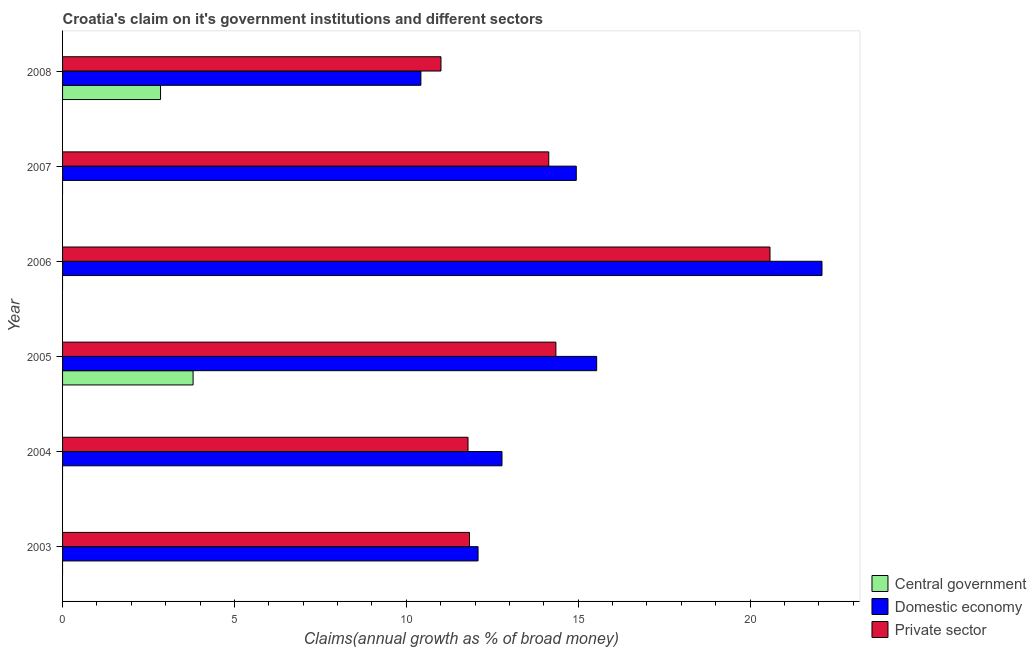How many different coloured bars are there?
Your response must be concise. 3. Are the number of bars per tick equal to the number of legend labels?
Give a very brief answer. No. How many bars are there on the 4th tick from the bottom?
Your response must be concise. 2. What is the label of the 4th group of bars from the top?
Give a very brief answer. 2005. Across all years, what is the maximum percentage of claim on the central government?
Keep it short and to the point. 3.8. Across all years, what is the minimum percentage of claim on the private sector?
Provide a short and direct response. 11.01. What is the total percentage of claim on the central government in the graph?
Provide a short and direct response. 6.65. What is the difference between the percentage of claim on the domestic economy in 2005 and that in 2007?
Provide a succinct answer. 0.59. What is the difference between the percentage of claim on the private sector in 2007 and the percentage of claim on the domestic economy in 2005?
Provide a short and direct response. -1.39. What is the average percentage of claim on the central government per year?
Make the answer very short. 1.11. In the year 2005, what is the difference between the percentage of claim on the domestic economy and percentage of claim on the private sector?
Keep it short and to the point. 1.19. What is the ratio of the percentage of claim on the private sector in 2004 to that in 2008?
Offer a terse response. 1.07. What is the difference between the highest and the second highest percentage of claim on the domestic economy?
Your answer should be compact. 6.55. What is the difference between the highest and the lowest percentage of claim on the central government?
Ensure brevity in your answer.  3.8. In how many years, is the percentage of claim on the domestic economy greater than the average percentage of claim on the domestic economy taken over all years?
Provide a short and direct response. 3. How many bars are there?
Offer a very short reply. 14. Are all the bars in the graph horizontal?
Provide a short and direct response. Yes. Are the values on the major ticks of X-axis written in scientific E-notation?
Keep it short and to the point. No. Does the graph contain any zero values?
Provide a succinct answer. Yes. Where does the legend appear in the graph?
Ensure brevity in your answer.  Bottom right. How many legend labels are there?
Offer a very short reply. 3. What is the title of the graph?
Ensure brevity in your answer.  Croatia's claim on it's government institutions and different sectors. Does "Spain" appear as one of the legend labels in the graph?
Keep it short and to the point. No. What is the label or title of the X-axis?
Your answer should be very brief. Claims(annual growth as % of broad money). What is the Claims(annual growth as % of broad money) of Central government in 2003?
Offer a terse response. 0. What is the Claims(annual growth as % of broad money) in Domestic economy in 2003?
Make the answer very short. 12.09. What is the Claims(annual growth as % of broad money) of Private sector in 2003?
Your answer should be compact. 11.84. What is the Claims(annual growth as % of broad money) in Domestic economy in 2004?
Offer a terse response. 12.78. What is the Claims(annual growth as % of broad money) in Private sector in 2004?
Provide a succinct answer. 11.8. What is the Claims(annual growth as % of broad money) in Central government in 2005?
Provide a short and direct response. 3.8. What is the Claims(annual growth as % of broad money) in Domestic economy in 2005?
Keep it short and to the point. 15.54. What is the Claims(annual growth as % of broad money) of Private sector in 2005?
Your response must be concise. 14.35. What is the Claims(annual growth as % of broad money) of Domestic economy in 2006?
Give a very brief answer. 22.09. What is the Claims(annual growth as % of broad money) of Private sector in 2006?
Keep it short and to the point. 20.58. What is the Claims(annual growth as % of broad money) of Domestic economy in 2007?
Offer a very short reply. 14.94. What is the Claims(annual growth as % of broad money) of Private sector in 2007?
Your response must be concise. 14.14. What is the Claims(annual growth as % of broad money) of Central government in 2008?
Offer a terse response. 2.85. What is the Claims(annual growth as % of broad money) of Domestic economy in 2008?
Provide a short and direct response. 10.42. What is the Claims(annual growth as % of broad money) in Private sector in 2008?
Ensure brevity in your answer.  11.01. Across all years, what is the maximum Claims(annual growth as % of broad money) in Central government?
Ensure brevity in your answer.  3.8. Across all years, what is the maximum Claims(annual growth as % of broad money) of Domestic economy?
Provide a short and direct response. 22.09. Across all years, what is the maximum Claims(annual growth as % of broad money) of Private sector?
Offer a terse response. 20.58. Across all years, what is the minimum Claims(annual growth as % of broad money) of Domestic economy?
Make the answer very short. 10.42. Across all years, what is the minimum Claims(annual growth as % of broad money) in Private sector?
Provide a short and direct response. 11.01. What is the total Claims(annual growth as % of broad money) of Central government in the graph?
Your answer should be very brief. 6.65. What is the total Claims(annual growth as % of broad money) of Domestic economy in the graph?
Provide a short and direct response. 87.87. What is the total Claims(annual growth as % of broad money) in Private sector in the graph?
Offer a terse response. 83.72. What is the difference between the Claims(annual growth as % of broad money) in Domestic economy in 2003 and that in 2004?
Provide a succinct answer. -0.7. What is the difference between the Claims(annual growth as % of broad money) in Private sector in 2003 and that in 2004?
Offer a terse response. 0.04. What is the difference between the Claims(annual growth as % of broad money) in Domestic economy in 2003 and that in 2005?
Keep it short and to the point. -3.45. What is the difference between the Claims(annual growth as % of broad money) in Private sector in 2003 and that in 2005?
Your answer should be compact. -2.51. What is the difference between the Claims(annual growth as % of broad money) in Domestic economy in 2003 and that in 2006?
Give a very brief answer. -10.01. What is the difference between the Claims(annual growth as % of broad money) in Private sector in 2003 and that in 2006?
Keep it short and to the point. -8.74. What is the difference between the Claims(annual growth as % of broad money) in Domestic economy in 2003 and that in 2007?
Provide a succinct answer. -2.86. What is the difference between the Claims(annual growth as % of broad money) in Private sector in 2003 and that in 2007?
Ensure brevity in your answer.  -2.31. What is the difference between the Claims(annual growth as % of broad money) of Domestic economy in 2003 and that in 2008?
Offer a very short reply. 1.66. What is the difference between the Claims(annual growth as % of broad money) of Private sector in 2003 and that in 2008?
Ensure brevity in your answer.  0.83. What is the difference between the Claims(annual growth as % of broad money) in Domestic economy in 2004 and that in 2005?
Provide a succinct answer. -2.75. What is the difference between the Claims(annual growth as % of broad money) of Private sector in 2004 and that in 2005?
Give a very brief answer. -2.56. What is the difference between the Claims(annual growth as % of broad money) of Domestic economy in 2004 and that in 2006?
Provide a short and direct response. -9.31. What is the difference between the Claims(annual growth as % of broad money) in Private sector in 2004 and that in 2006?
Ensure brevity in your answer.  -8.78. What is the difference between the Claims(annual growth as % of broad money) in Domestic economy in 2004 and that in 2007?
Your answer should be very brief. -2.16. What is the difference between the Claims(annual growth as % of broad money) in Private sector in 2004 and that in 2007?
Keep it short and to the point. -2.35. What is the difference between the Claims(annual growth as % of broad money) in Domestic economy in 2004 and that in 2008?
Ensure brevity in your answer.  2.36. What is the difference between the Claims(annual growth as % of broad money) in Private sector in 2004 and that in 2008?
Offer a terse response. 0.79. What is the difference between the Claims(annual growth as % of broad money) of Domestic economy in 2005 and that in 2006?
Ensure brevity in your answer.  -6.55. What is the difference between the Claims(annual growth as % of broad money) of Private sector in 2005 and that in 2006?
Provide a short and direct response. -6.23. What is the difference between the Claims(annual growth as % of broad money) in Domestic economy in 2005 and that in 2007?
Ensure brevity in your answer.  0.59. What is the difference between the Claims(annual growth as % of broad money) in Private sector in 2005 and that in 2007?
Your answer should be compact. 0.21. What is the difference between the Claims(annual growth as % of broad money) in Central government in 2005 and that in 2008?
Your answer should be very brief. 0.95. What is the difference between the Claims(annual growth as % of broad money) of Domestic economy in 2005 and that in 2008?
Your response must be concise. 5.11. What is the difference between the Claims(annual growth as % of broad money) of Private sector in 2005 and that in 2008?
Ensure brevity in your answer.  3.34. What is the difference between the Claims(annual growth as % of broad money) in Domestic economy in 2006 and that in 2007?
Keep it short and to the point. 7.15. What is the difference between the Claims(annual growth as % of broad money) in Private sector in 2006 and that in 2007?
Ensure brevity in your answer.  6.44. What is the difference between the Claims(annual growth as % of broad money) in Domestic economy in 2006 and that in 2008?
Keep it short and to the point. 11.67. What is the difference between the Claims(annual growth as % of broad money) in Private sector in 2006 and that in 2008?
Keep it short and to the point. 9.57. What is the difference between the Claims(annual growth as % of broad money) of Domestic economy in 2007 and that in 2008?
Your answer should be compact. 4.52. What is the difference between the Claims(annual growth as % of broad money) of Private sector in 2007 and that in 2008?
Give a very brief answer. 3.14. What is the difference between the Claims(annual growth as % of broad money) in Domestic economy in 2003 and the Claims(annual growth as % of broad money) in Private sector in 2004?
Provide a short and direct response. 0.29. What is the difference between the Claims(annual growth as % of broad money) in Domestic economy in 2003 and the Claims(annual growth as % of broad money) in Private sector in 2005?
Ensure brevity in your answer.  -2.26. What is the difference between the Claims(annual growth as % of broad money) of Domestic economy in 2003 and the Claims(annual growth as % of broad money) of Private sector in 2006?
Your response must be concise. -8.49. What is the difference between the Claims(annual growth as % of broad money) of Domestic economy in 2003 and the Claims(annual growth as % of broad money) of Private sector in 2007?
Your answer should be very brief. -2.06. What is the difference between the Claims(annual growth as % of broad money) of Domestic economy in 2003 and the Claims(annual growth as % of broad money) of Private sector in 2008?
Make the answer very short. 1.08. What is the difference between the Claims(annual growth as % of broad money) of Domestic economy in 2004 and the Claims(annual growth as % of broad money) of Private sector in 2005?
Offer a terse response. -1.57. What is the difference between the Claims(annual growth as % of broad money) in Domestic economy in 2004 and the Claims(annual growth as % of broad money) in Private sector in 2006?
Your answer should be compact. -7.8. What is the difference between the Claims(annual growth as % of broad money) of Domestic economy in 2004 and the Claims(annual growth as % of broad money) of Private sector in 2007?
Offer a very short reply. -1.36. What is the difference between the Claims(annual growth as % of broad money) of Domestic economy in 2004 and the Claims(annual growth as % of broad money) of Private sector in 2008?
Offer a terse response. 1.77. What is the difference between the Claims(annual growth as % of broad money) of Central government in 2005 and the Claims(annual growth as % of broad money) of Domestic economy in 2006?
Your answer should be very brief. -18.3. What is the difference between the Claims(annual growth as % of broad money) of Central government in 2005 and the Claims(annual growth as % of broad money) of Private sector in 2006?
Your answer should be very brief. -16.78. What is the difference between the Claims(annual growth as % of broad money) of Domestic economy in 2005 and the Claims(annual growth as % of broad money) of Private sector in 2006?
Keep it short and to the point. -5.04. What is the difference between the Claims(annual growth as % of broad money) in Central government in 2005 and the Claims(annual growth as % of broad money) in Domestic economy in 2007?
Provide a succinct answer. -11.15. What is the difference between the Claims(annual growth as % of broad money) of Central government in 2005 and the Claims(annual growth as % of broad money) of Private sector in 2007?
Give a very brief answer. -10.35. What is the difference between the Claims(annual growth as % of broad money) of Domestic economy in 2005 and the Claims(annual growth as % of broad money) of Private sector in 2007?
Ensure brevity in your answer.  1.39. What is the difference between the Claims(annual growth as % of broad money) of Central government in 2005 and the Claims(annual growth as % of broad money) of Domestic economy in 2008?
Provide a succinct answer. -6.63. What is the difference between the Claims(annual growth as % of broad money) in Central government in 2005 and the Claims(annual growth as % of broad money) in Private sector in 2008?
Offer a very short reply. -7.21. What is the difference between the Claims(annual growth as % of broad money) of Domestic economy in 2005 and the Claims(annual growth as % of broad money) of Private sector in 2008?
Offer a very short reply. 4.53. What is the difference between the Claims(annual growth as % of broad money) in Domestic economy in 2006 and the Claims(annual growth as % of broad money) in Private sector in 2007?
Ensure brevity in your answer.  7.95. What is the difference between the Claims(annual growth as % of broad money) of Domestic economy in 2006 and the Claims(annual growth as % of broad money) of Private sector in 2008?
Make the answer very short. 11.08. What is the difference between the Claims(annual growth as % of broad money) in Domestic economy in 2007 and the Claims(annual growth as % of broad money) in Private sector in 2008?
Provide a short and direct response. 3.94. What is the average Claims(annual growth as % of broad money) in Central government per year?
Offer a very short reply. 1.11. What is the average Claims(annual growth as % of broad money) of Domestic economy per year?
Provide a short and direct response. 14.64. What is the average Claims(annual growth as % of broad money) in Private sector per year?
Your answer should be compact. 13.95. In the year 2003, what is the difference between the Claims(annual growth as % of broad money) of Domestic economy and Claims(annual growth as % of broad money) of Private sector?
Provide a short and direct response. 0.25. In the year 2004, what is the difference between the Claims(annual growth as % of broad money) of Domestic economy and Claims(annual growth as % of broad money) of Private sector?
Your response must be concise. 0.99. In the year 2005, what is the difference between the Claims(annual growth as % of broad money) of Central government and Claims(annual growth as % of broad money) of Domestic economy?
Offer a very short reply. -11.74. In the year 2005, what is the difference between the Claims(annual growth as % of broad money) of Central government and Claims(annual growth as % of broad money) of Private sector?
Provide a short and direct response. -10.55. In the year 2005, what is the difference between the Claims(annual growth as % of broad money) of Domestic economy and Claims(annual growth as % of broad money) of Private sector?
Make the answer very short. 1.19. In the year 2006, what is the difference between the Claims(annual growth as % of broad money) of Domestic economy and Claims(annual growth as % of broad money) of Private sector?
Your response must be concise. 1.51. In the year 2007, what is the difference between the Claims(annual growth as % of broad money) in Domestic economy and Claims(annual growth as % of broad money) in Private sector?
Your response must be concise. 0.8. In the year 2008, what is the difference between the Claims(annual growth as % of broad money) of Central government and Claims(annual growth as % of broad money) of Domestic economy?
Offer a terse response. -7.57. In the year 2008, what is the difference between the Claims(annual growth as % of broad money) of Central government and Claims(annual growth as % of broad money) of Private sector?
Ensure brevity in your answer.  -8.16. In the year 2008, what is the difference between the Claims(annual growth as % of broad money) in Domestic economy and Claims(annual growth as % of broad money) in Private sector?
Keep it short and to the point. -0.58. What is the ratio of the Claims(annual growth as % of broad money) in Domestic economy in 2003 to that in 2004?
Provide a succinct answer. 0.95. What is the ratio of the Claims(annual growth as % of broad money) in Private sector in 2003 to that in 2004?
Your response must be concise. 1. What is the ratio of the Claims(annual growth as % of broad money) in Domestic economy in 2003 to that in 2005?
Ensure brevity in your answer.  0.78. What is the ratio of the Claims(annual growth as % of broad money) of Private sector in 2003 to that in 2005?
Keep it short and to the point. 0.82. What is the ratio of the Claims(annual growth as % of broad money) of Domestic economy in 2003 to that in 2006?
Your response must be concise. 0.55. What is the ratio of the Claims(annual growth as % of broad money) in Private sector in 2003 to that in 2006?
Give a very brief answer. 0.58. What is the ratio of the Claims(annual growth as % of broad money) of Domestic economy in 2003 to that in 2007?
Offer a terse response. 0.81. What is the ratio of the Claims(annual growth as % of broad money) of Private sector in 2003 to that in 2007?
Your answer should be very brief. 0.84. What is the ratio of the Claims(annual growth as % of broad money) in Domestic economy in 2003 to that in 2008?
Give a very brief answer. 1.16. What is the ratio of the Claims(annual growth as % of broad money) in Private sector in 2003 to that in 2008?
Offer a very short reply. 1.08. What is the ratio of the Claims(annual growth as % of broad money) in Domestic economy in 2004 to that in 2005?
Give a very brief answer. 0.82. What is the ratio of the Claims(annual growth as % of broad money) in Private sector in 2004 to that in 2005?
Your response must be concise. 0.82. What is the ratio of the Claims(annual growth as % of broad money) of Domestic economy in 2004 to that in 2006?
Offer a terse response. 0.58. What is the ratio of the Claims(annual growth as % of broad money) of Private sector in 2004 to that in 2006?
Keep it short and to the point. 0.57. What is the ratio of the Claims(annual growth as % of broad money) in Domestic economy in 2004 to that in 2007?
Your answer should be very brief. 0.86. What is the ratio of the Claims(annual growth as % of broad money) of Private sector in 2004 to that in 2007?
Ensure brevity in your answer.  0.83. What is the ratio of the Claims(annual growth as % of broad money) in Domestic economy in 2004 to that in 2008?
Offer a terse response. 1.23. What is the ratio of the Claims(annual growth as % of broad money) of Private sector in 2004 to that in 2008?
Provide a succinct answer. 1.07. What is the ratio of the Claims(annual growth as % of broad money) of Domestic economy in 2005 to that in 2006?
Your answer should be compact. 0.7. What is the ratio of the Claims(annual growth as % of broad money) of Private sector in 2005 to that in 2006?
Provide a succinct answer. 0.7. What is the ratio of the Claims(annual growth as % of broad money) of Domestic economy in 2005 to that in 2007?
Make the answer very short. 1.04. What is the ratio of the Claims(annual growth as % of broad money) in Private sector in 2005 to that in 2007?
Your answer should be very brief. 1.01. What is the ratio of the Claims(annual growth as % of broad money) in Central government in 2005 to that in 2008?
Your response must be concise. 1.33. What is the ratio of the Claims(annual growth as % of broad money) in Domestic economy in 2005 to that in 2008?
Provide a succinct answer. 1.49. What is the ratio of the Claims(annual growth as % of broad money) in Private sector in 2005 to that in 2008?
Ensure brevity in your answer.  1.3. What is the ratio of the Claims(annual growth as % of broad money) of Domestic economy in 2006 to that in 2007?
Provide a succinct answer. 1.48. What is the ratio of the Claims(annual growth as % of broad money) of Private sector in 2006 to that in 2007?
Your response must be concise. 1.46. What is the ratio of the Claims(annual growth as % of broad money) in Domestic economy in 2006 to that in 2008?
Give a very brief answer. 2.12. What is the ratio of the Claims(annual growth as % of broad money) of Private sector in 2006 to that in 2008?
Your answer should be very brief. 1.87. What is the ratio of the Claims(annual growth as % of broad money) of Domestic economy in 2007 to that in 2008?
Your answer should be compact. 1.43. What is the ratio of the Claims(annual growth as % of broad money) of Private sector in 2007 to that in 2008?
Your response must be concise. 1.28. What is the difference between the highest and the second highest Claims(annual growth as % of broad money) of Domestic economy?
Offer a very short reply. 6.55. What is the difference between the highest and the second highest Claims(annual growth as % of broad money) of Private sector?
Keep it short and to the point. 6.23. What is the difference between the highest and the lowest Claims(annual growth as % of broad money) of Central government?
Your answer should be compact. 3.8. What is the difference between the highest and the lowest Claims(annual growth as % of broad money) in Domestic economy?
Provide a short and direct response. 11.67. What is the difference between the highest and the lowest Claims(annual growth as % of broad money) in Private sector?
Your response must be concise. 9.57. 